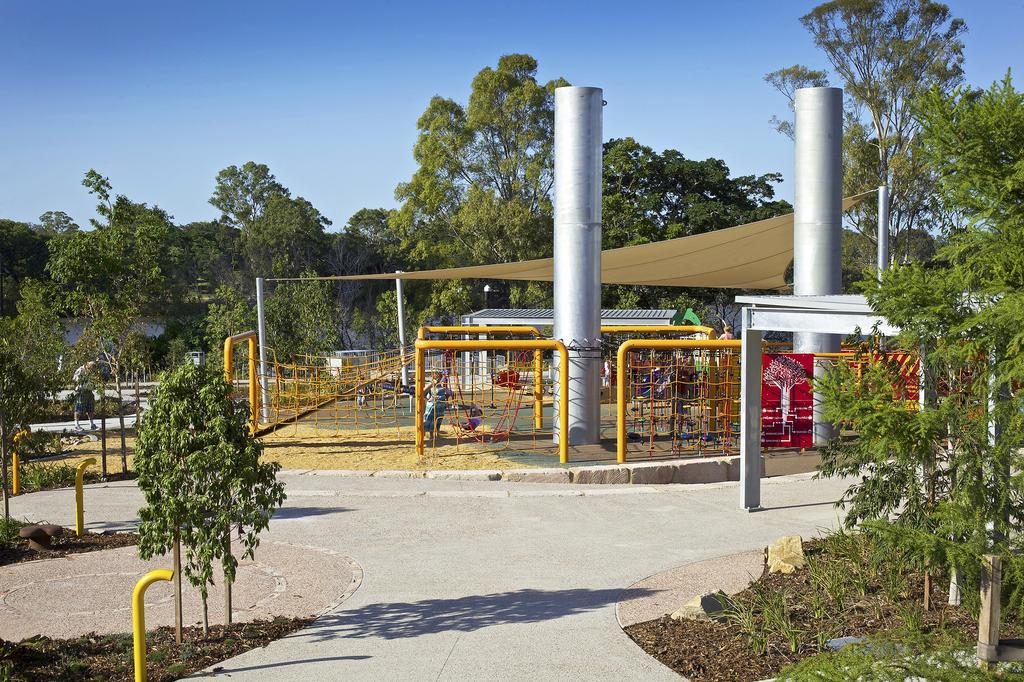What type of objects can be seen in the image that are made of metal? There are metal rods in the image. What other objects can be seen in the image that are similar to the metal rods? There are poles in the image. What type of shelter is visible in the image? There is a tent in the image. Who or what is inside the tent? There are people in the image, but it is not clear if they are inside the tent. What can be seen in the background of the image? There are trees in the background of the image. How many ladybugs can be seen crawling on the tent in the image? There are no ladybugs visible in the image. What type of celebration is taking place in the image? There is no indication of a celebration or birthday in the image. 